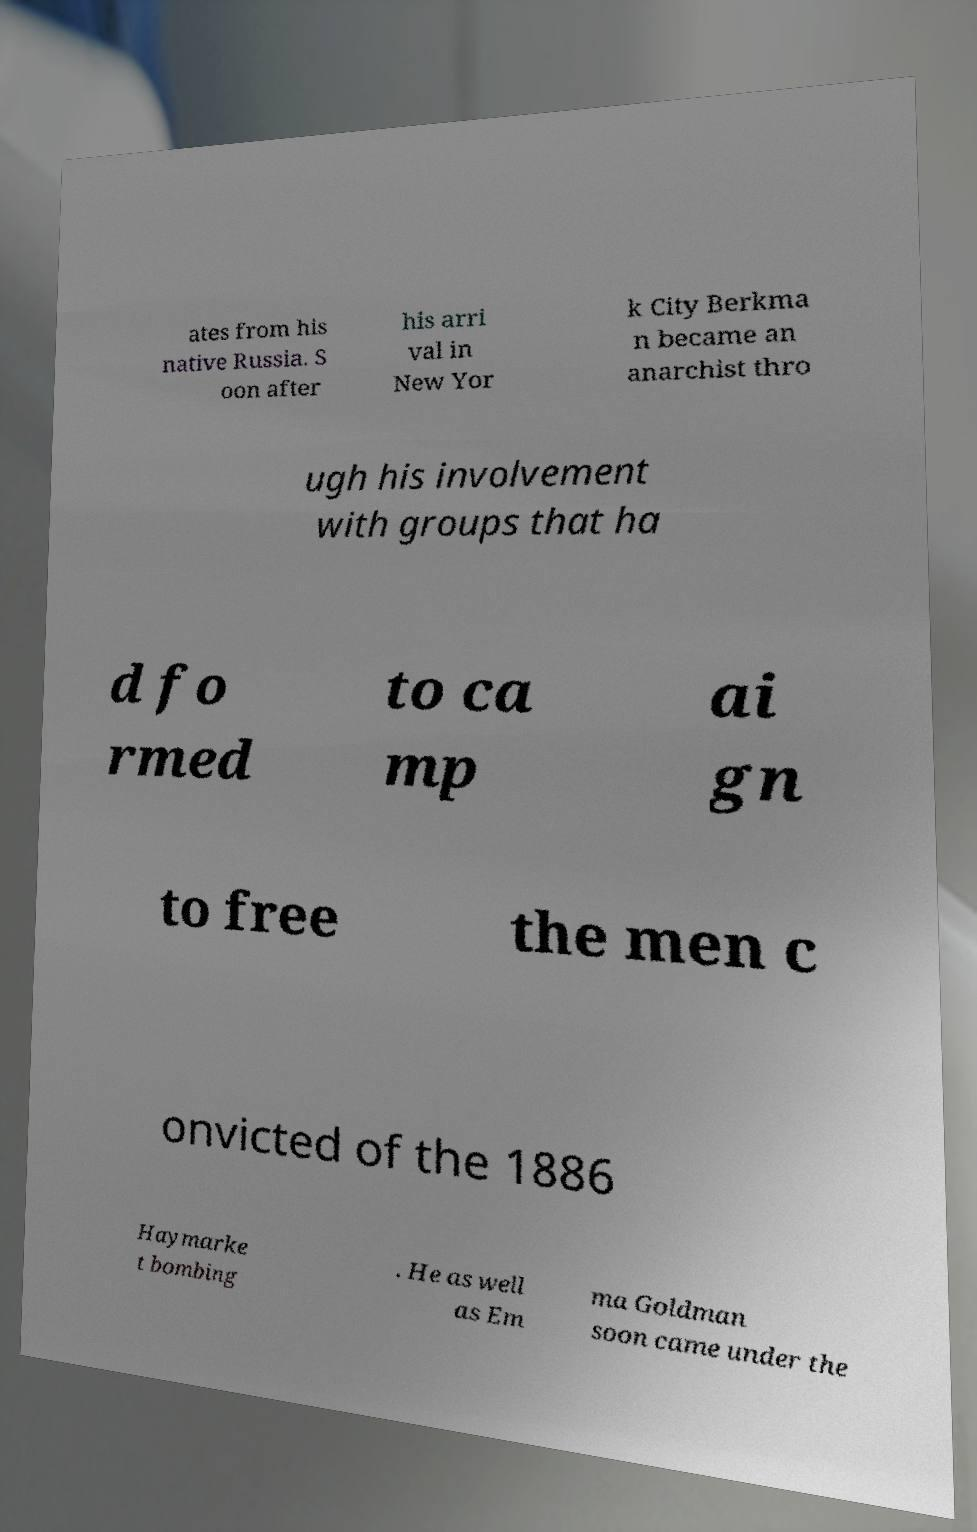For documentation purposes, I need the text within this image transcribed. Could you provide that? ates from his native Russia. S oon after his arri val in New Yor k City Berkma n became an anarchist thro ugh his involvement with groups that ha d fo rmed to ca mp ai gn to free the men c onvicted of the 1886 Haymarke t bombing . He as well as Em ma Goldman soon came under the 